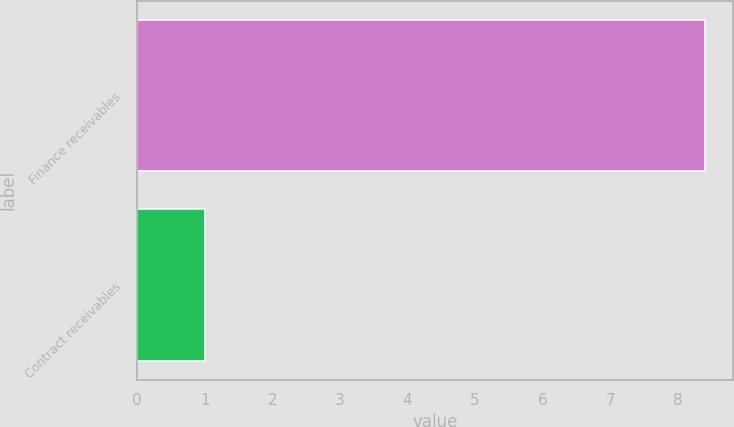Convert chart to OTSL. <chart><loc_0><loc_0><loc_500><loc_500><bar_chart><fcel>Finance receivables<fcel>Contract receivables<nl><fcel>8.4<fcel>1<nl></chart> 